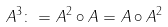Convert formula to latex. <formula><loc_0><loc_0><loc_500><loc_500>A ^ { 3 } \colon = A ^ { 2 } \circ A = A \circ A ^ { 2 }</formula> 